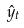<formula> <loc_0><loc_0><loc_500><loc_500>\hat { y } _ { t }</formula> 